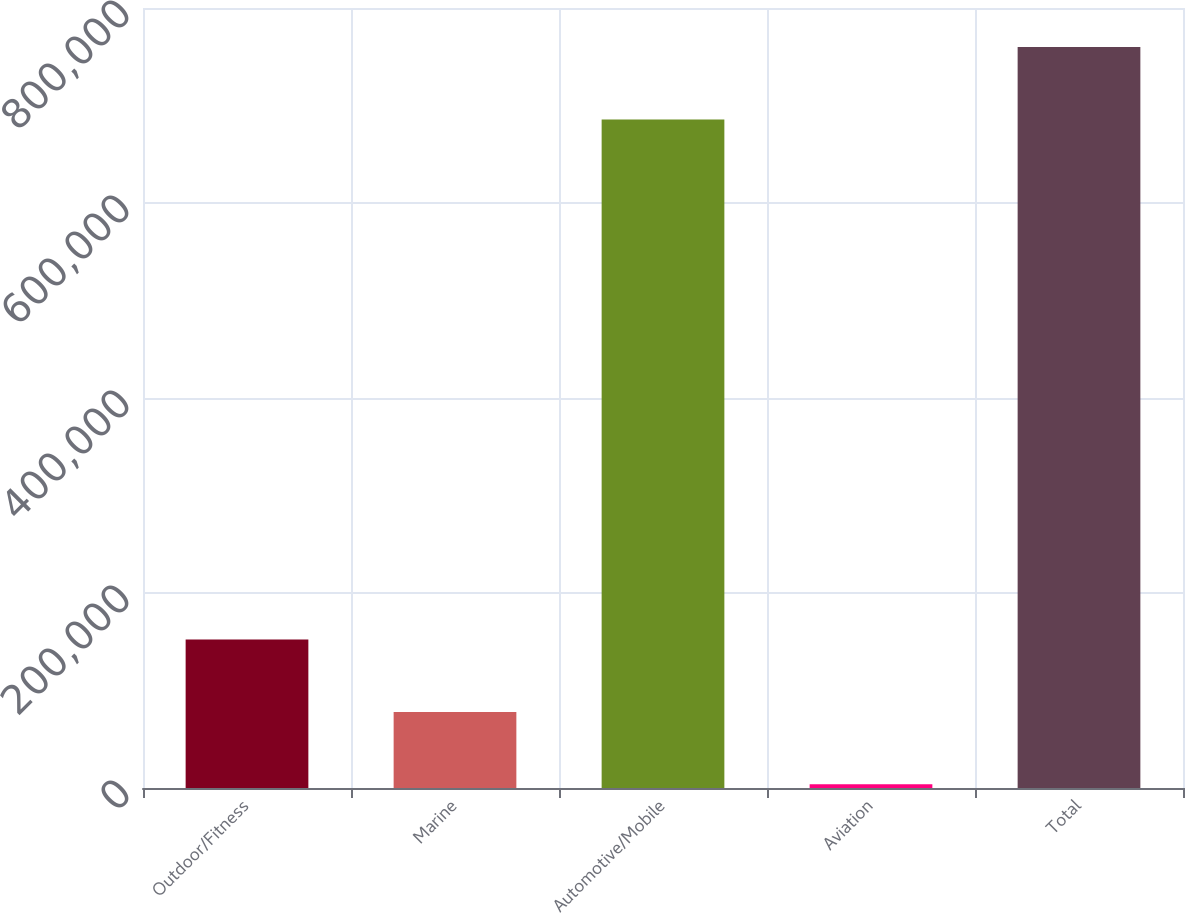Convert chart to OTSL. <chart><loc_0><loc_0><loc_500><loc_500><bar_chart><fcel>Outdoor/Fitness<fcel>Marine<fcel>Automotive/Mobile<fcel>Aviation<fcel>Total<nl><fcel>152244<fcel>77995.9<fcel>685676<fcel>3748<fcel>759924<nl></chart> 